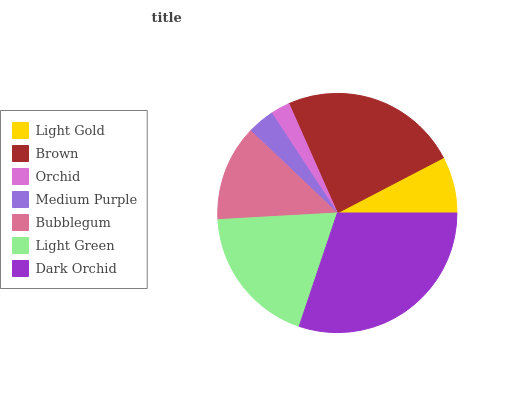Is Orchid the minimum?
Answer yes or no. Yes. Is Dark Orchid the maximum?
Answer yes or no. Yes. Is Brown the minimum?
Answer yes or no. No. Is Brown the maximum?
Answer yes or no. No. Is Brown greater than Light Gold?
Answer yes or no. Yes. Is Light Gold less than Brown?
Answer yes or no. Yes. Is Light Gold greater than Brown?
Answer yes or no. No. Is Brown less than Light Gold?
Answer yes or no. No. Is Bubblegum the high median?
Answer yes or no. Yes. Is Bubblegum the low median?
Answer yes or no. Yes. Is Light Gold the high median?
Answer yes or no. No. Is Brown the low median?
Answer yes or no. No. 